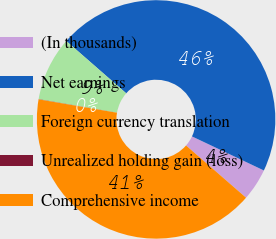<chart> <loc_0><loc_0><loc_500><loc_500><pie_chart><fcel>(In thousands)<fcel>Net earnings<fcel>Foreign currency translation<fcel>Unrealized holding gain (loss)<fcel>Comprehensive income<nl><fcel>4.36%<fcel>45.62%<fcel>8.7%<fcel>0.03%<fcel>41.29%<nl></chart> 